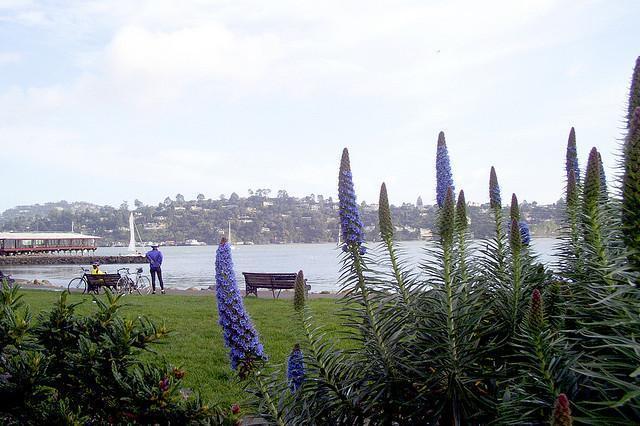How many chairs are there?
Give a very brief answer. 2. How many trains have a number on the front?
Give a very brief answer. 0. 